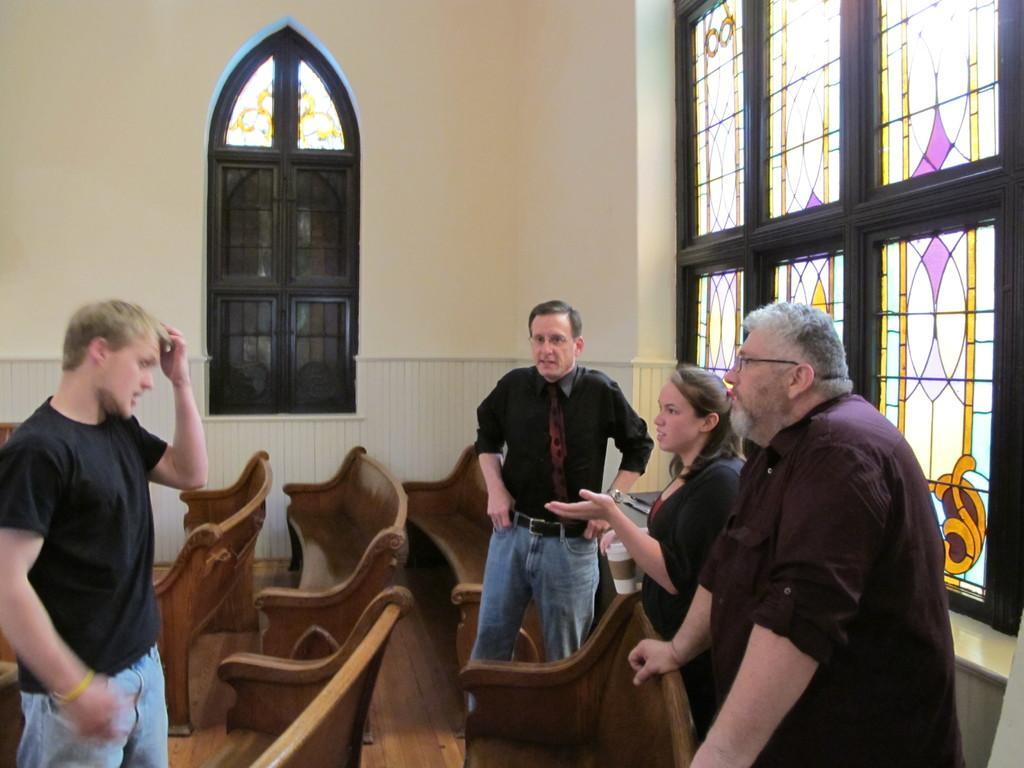Could you give a brief overview of what you see in this image? In this image we can see four persons standing. Beside the persons we can see the benches. Behind the persons we can see the wall. On the wall we can see the windows. 